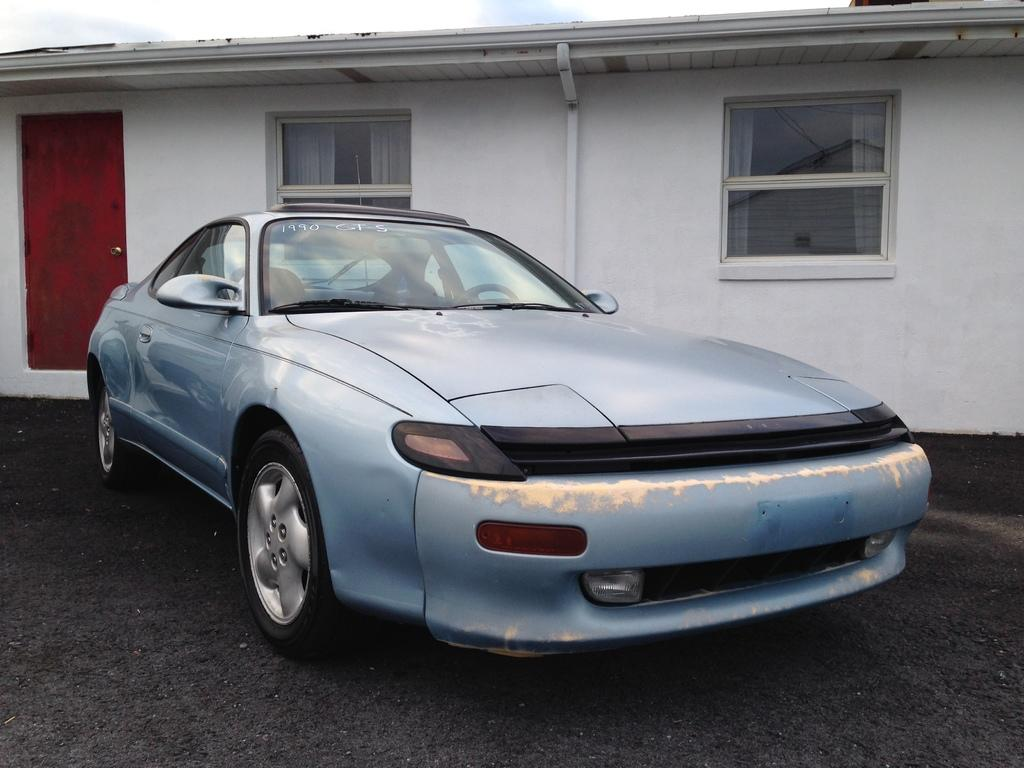What is the main subject in the center of the image? There is a car in the center of the image. What can be seen in the background of the image? Sky, clouds, windows, a building, a wall, a pipe, and a door are present in the background of the image. Can you describe the sky in the background? The sky is visible in the background of the image. What type of structure can be seen in the background? There is a building in the background of the image. What does your mom say about the downtown area in the image? There is no mention of a downtown area or your mom in the image. 